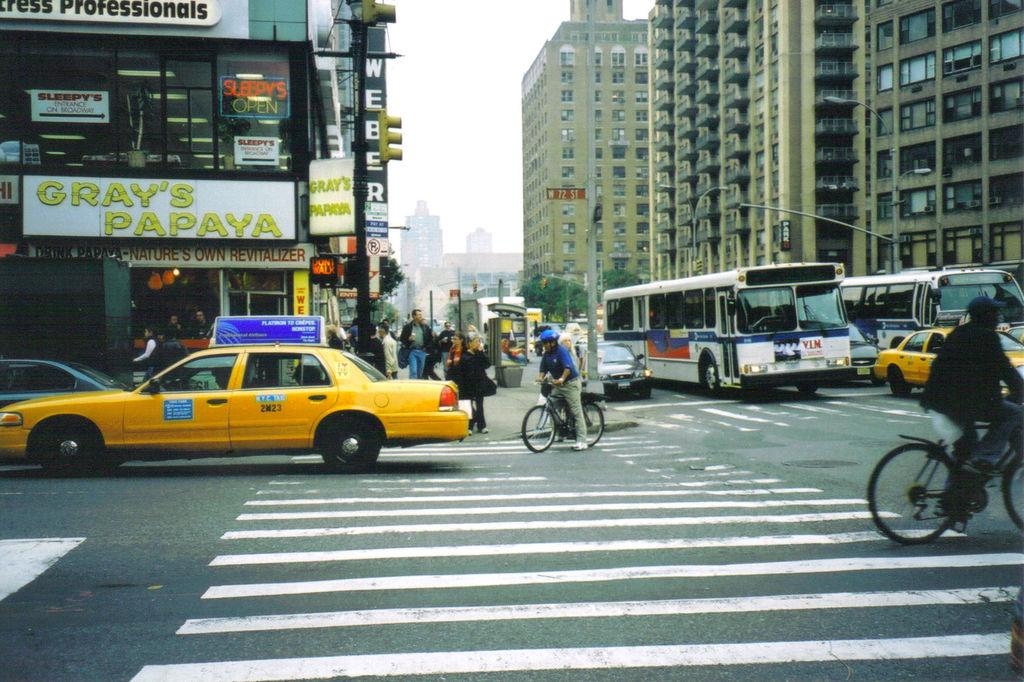<image>
Create a compact narrative representing the image presented. A taxi cab drives in front of Gray's Papaya store. 